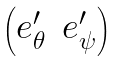Convert formula to latex. <formula><loc_0><loc_0><loc_500><loc_500>\begin{pmatrix} e _ { \theta } ^ { \prime } & e _ { \psi } ^ { \prime } \end{pmatrix}</formula> 